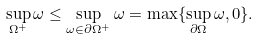Convert formula to latex. <formula><loc_0><loc_0><loc_500><loc_500>\sup _ { \Omega ^ { + } } \omega \leq \sup _ { \omega \in \partial \Omega ^ { + } } \omega = \max \{ \sup _ { \partial \Omega } \omega , 0 \} .</formula> 